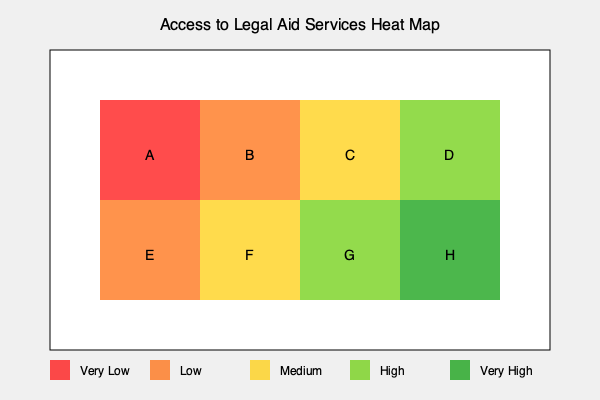Based on the heat map provided, which region shows the greatest disparity in access to legal aid services, and what implications does this have for addressing systemic inequalities in the legal system? To answer this question, we need to analyze the heat map and interpret its implications:

1. Interpret the heat map:
   - Red (very low access) to dark green (very high access)
   - The map is divided into 8 regions (A-H)

2. Identify the region with the greatest disparity:
   - Region A (top-left) shows very low access (red)
   - Region H (bottom-right) shows very high access (dark green)
   - The diagonal from A to H represents the greatest disparity

3. Implications for systemic inequalities:
   a) Unequal access to justice:
      - People in region A have significantly less access to legal aid than those in region H
      - This can lead to unequal representation and outcomes in legal proceedings

   b) Perpetuation of socioeconomic disparities:
      - Areas with low access to legal aid may correlate with lower-income or marginalized communities
      - This reinforces existing inequalities by limiting access to legal resources

   c) Geographical injustice:
      - The stark contrast between regions suggests a geographical component to legal inequality
      - This may reflect urban-rural divides or other spatial factors in resource allocation

   d) Potential for discriminatory practices:
      - The pattern could indicate systemic bias in the distribution of legal resources
      - This may violate principles of equal protection under the law

   e) Need for targeted interventions:
      - The heat map highlights areas (like region A) where increased legal aid services are critically needed
      - Policy makers and legal professionals should focus on improving access in these underserved areas

   f) Opportunity for reform:
      - The clear visualization of disparities provides evidence for advocating legal system reforms
      - It can be used to support arguments for more equitable distribution of legal resources

By addressing these disparities, the legal system can work towards reducing systemic inequalities and ensuring more equitable access to justice across all regions.
Answer: The greatest disparity is between regions A and H, implying significant systemic inequalities in legal aid access that perpetuate socioeconomic disparities, geographical injustice, and potentially discriminatory practices, necessitating targeted interventions and systemic reforms. 